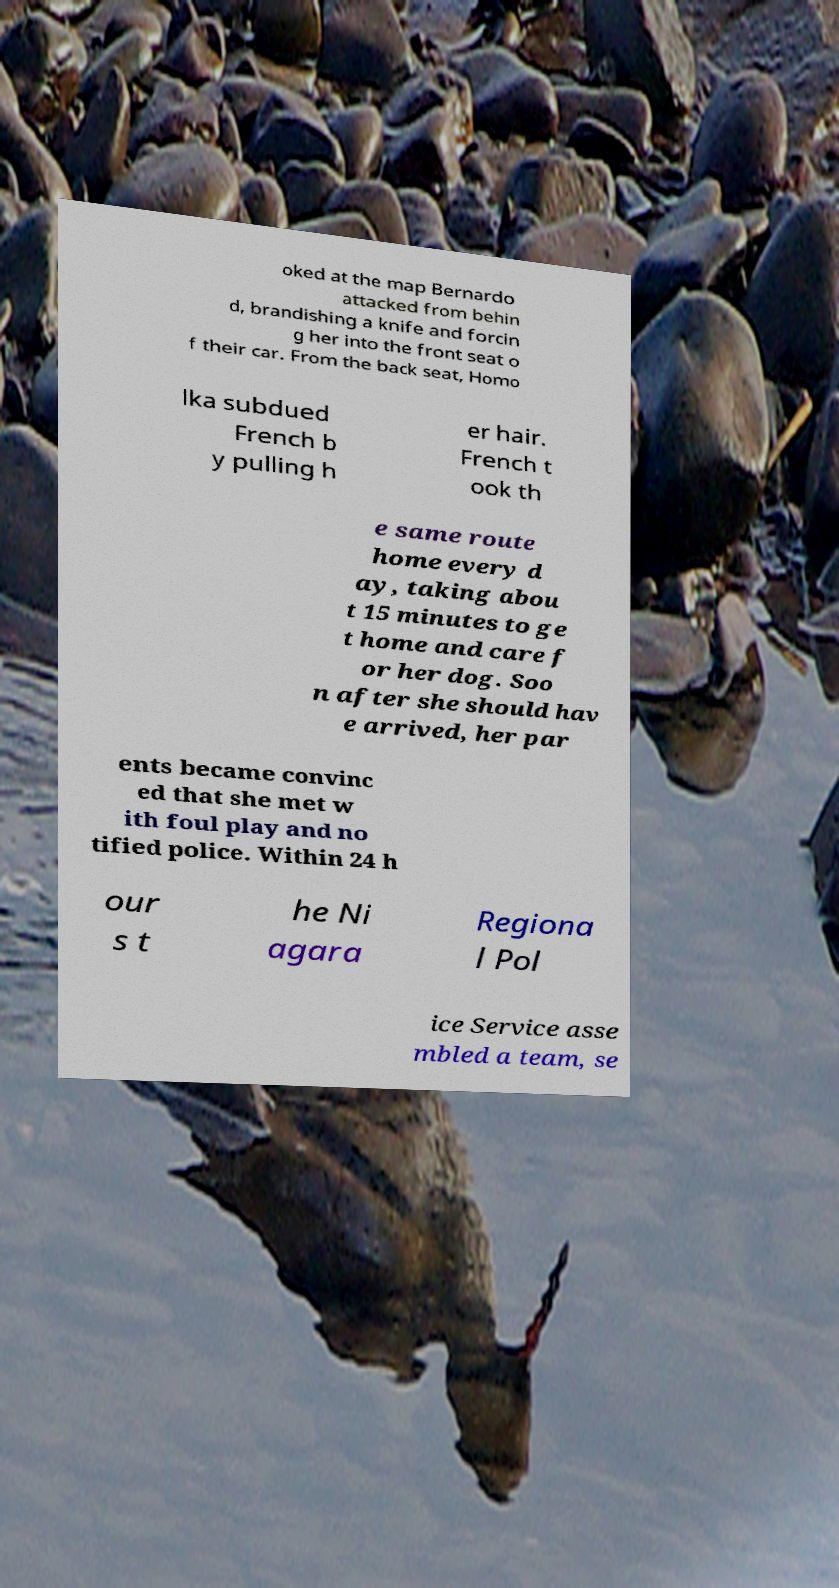Could you extract and type out the text from this image? oked at the map Bernardo attacked from behin d, brandishing a knife and forcin g her into the front seat o f their car. From the back seat, Homo lka subdued French b y pulling h er hair. French t ook th e same route home every d ay, taking abou t 15 minutes to ge t home and care f or her dog. Soo n after she should hav e arrived, her par ents became convinc ed that she met w ith foul play and no tified police. Within 24 h our s t he Ni agara Regiona l Pol ice Service asse mbled a team, se 